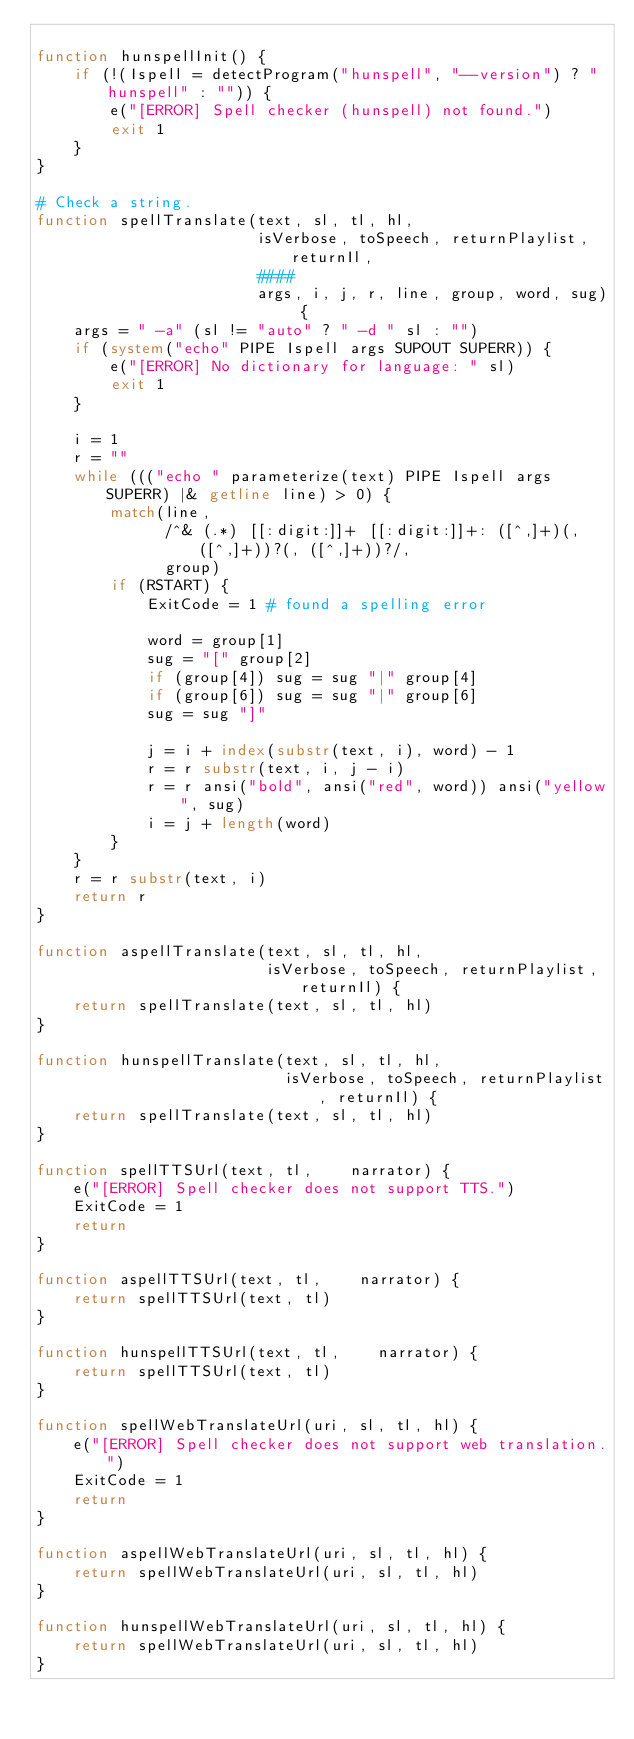<code> <loc_0><loc_0><loc_500><loc_500><_Awk_>
function hunspellInit() {
    if (!(Ispell = detectProgram("hunspell", "--version") ? "hunspell" : "")) {
        e("[ERROR] Spell checker (hunspell) not found.")
        exit 1
    }
}

# Check a string.
function spellTranslate(text, sl, tl, hl,
                        isVerbose, toSpeech, returnPlaylist, returnIl,
                        ####
                        args, i, j, r, line, group, word, sug) {
    args = " -a" (sl != "auto" ? " -d " sl : "")
    if (system("echo" PIPE Ispell args SUPOUT SUPERR)) {
        e("[ERROR] No dictionary for language: " sl)
        exit 1
    }

    i = 1
    r = ""
    while ((("echo " parameterize(text) PIPE Ispell args SUPERR) |& getline line) > 0) {
        match(line,
              /^& (.*) [[:digit:]]+ [[:digit:]]+: ([^,]+)(, ([^,]+))?(, ([^,]+))?/,
              group)
        if (RSTART) {
            ExitCode = 1 # found a spelling error

            word = group[1]
            sug = "[" group[2]
            if (group[4]) sug = sug "|" group[4]
            if (group[6]) sug = sug "|" group[6]
            sug = sug "]"

            j = i + index(substr(text, i), word) - 1
            r = r substr(text, i, j - i)
            r = r ansi("bold", ansi("red", word)) ansi("yellow", sug)
            i = j + length(word)
        }
    }
    r = r substr(text, i)
    return r
}

function aspellTranslate(text, sl, tl, hl,
                         isVerbose, toSpeech, returnPlaylist, returnIl) {
    return spellTranslate(text, sl, tl, hl)
}

function hunspellTranslate(text, sl, tl, hl,
                           isVerbose, toSpeech, returnPlaylist, returnIl) {
    return spellTranslate(text, sl, tl, hl)
}

function spellTTSUrl(text, tl,    narrator) {
    e("[ERROR] Spell checker does not support TTS.")
    ExitCode = 1
    return
}

function aspellTTSUrl(text, tl,    narrator) {
    return spellTTSUrl(text, tl)
}

function hunspellTTSUrl(text, tl,    narrator) {
    return spellTTSUrl(text, tl)
}

function spellWebTranslateUrl(uri, sl, tl, hl) {
    e("[ERROR] Spell checker does not support web translation.")
    ExitCode = 1
    return
}

function aspellWebTranslateUrl(uri, sl, tl, hl) {
    return spellWebTranslateUrl(uri, sl, tl, hl)
}

function hunspellWebTranslateUrl(uri, sl, tl, hl) {
    return spellWebTranslateUrl(uri, sl, tl, hl)
}
</code> 